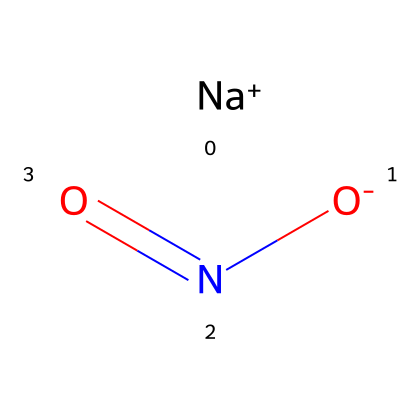What is the name of this chemical? The SMILES representation clearly defines the compound as sodium nitrite, indicated by the presence of sodium (Na) and the nitrite ion (NO2-).
Answer: sodium nitrite How many atoms are in this chemical structure? Counting the atoms represented in the SMILES, we have one sodium (Na), one nitrogen (N), and two oxygen (O). Therefore, the total number of atoms is four.
Answer: four What is the oxidation state of nitrogen in sodium nitrite? In the nitrite ion (NO2-), the nitrogen typically has an oxidation state of +3, which can be determined by considering the usual oxidation states of oxygen (-2) and the overall charge of the ion.
Answer: +3 Which type of bond is present between nitrogen and oxygen in sodium nitrite? The structure shows that nitrogen is bonded to two oxygen atoms with a double bond and a single bond; therefore, it includes both double and single bonds.
Answer: double and single bonds What is the role of sodium nitrite in food preservation? Sodium nitrite is primarily used as a preservative in cured meats to inhibit bacterial growth, particularly Clostridium botulinum, which is crucial for food safety.
Answer: food preservative Are there any health concerns associated with sodium nitrite? Yes, sodium nitrite can form carcinogenic nitrosamines when it reacts with amines under acidic conditions, raising health concerns related to its consumption in processed meats.
Answer: health concerns 